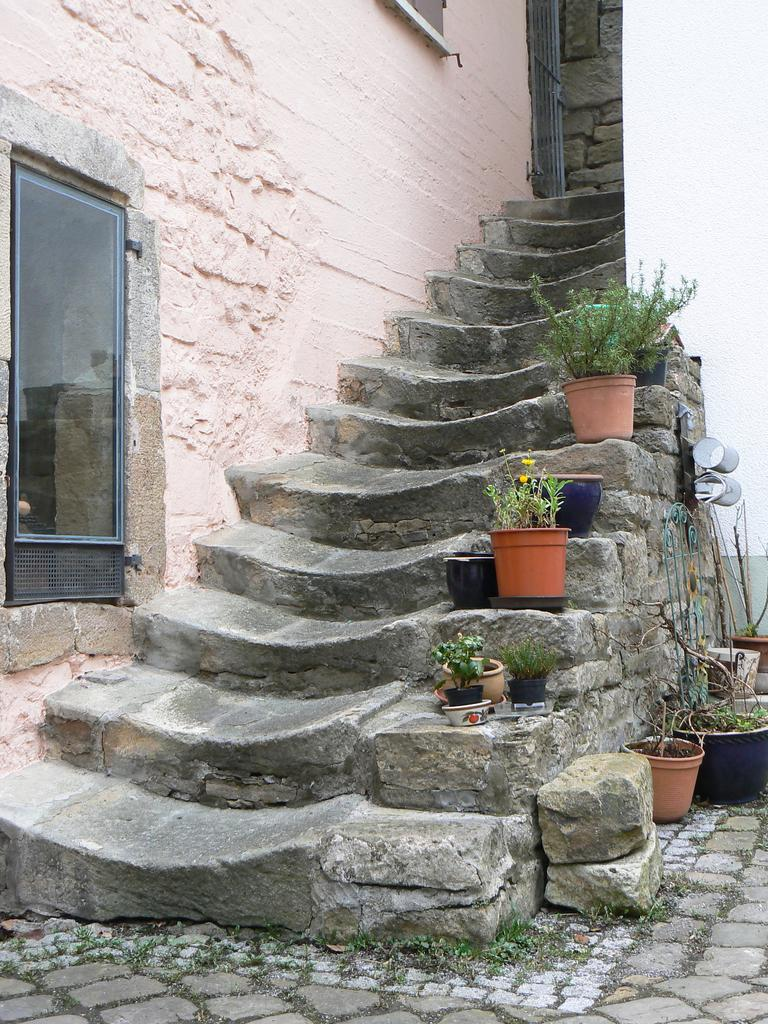What type of furniture is present in the image? There are state cases in the image. What is placed on top of the state cases? There are potted plants on the state cases. Can you describe the window in the image? There is a window visible in the image, and it is adjacent to a wall. What type of letters can be seen hanging from the silk curtains in the image? There are no silk curtains or letters present in the image. 